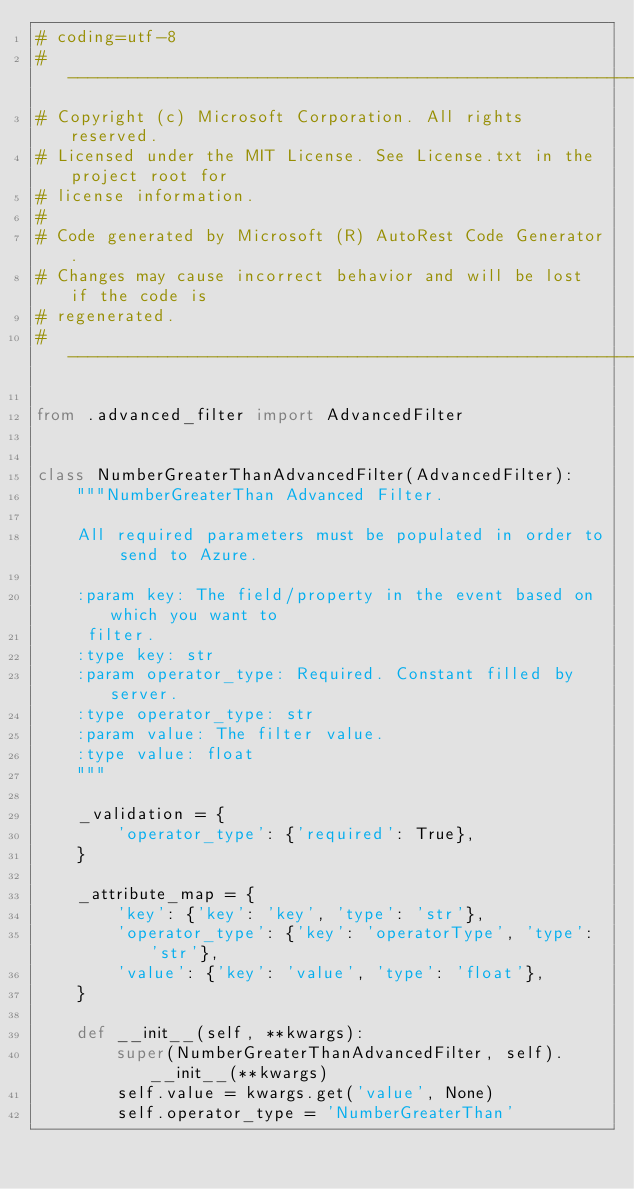Convert code to text. <code><loc_0><loc_0><loc_500><loc_500><_Python_># coding=utf-8
# --------------------------------------------------------------------------
# Copyright (c) Microsoft Corporation. All rights reserved.
# Licensed under the MIT License. See License.txt in the project root for
# license information.
#
# Code generated by Microsoft (R) AutoRest Code Generator.
# Changes may cause incorrect behavior and will be lost if the code is
# regenerated.
# --------------------------------------------------------------------------

from .advanced_filter import AdvancedFilter


class NumberGreaterThanAdvancedFilter(AdvancedFilter):
    """NumberGreaterThan Advanced Filter.

    All required parameters must be populated in order to send to Azure.

    :param key: The field/property in the event based on which you want to
     filter.
    :type key: str
    :param operator_type: Required. Constant filled by server.
    :type operator_type: str
    :param value: The filter value.
    :type value: float
    """

    _validation = {
        'operator_type': {'required': True},
    }

    _attribute_map = {
        'key': {'key': 'key', 'type': 'str'},
        'operator_type': {'key': 'operatorType', 'type': 'str'},
        'value': {'key': 'value', 'type': 'float'},
    }

    def __init__(self, **kwargs):
        super(NumberGreaterThanAdvancedFilter, self).__init__(**kwargs)
        self.value = kwargs.get('value', None)
        self.operator_type = 'NumberGreaterThan'
</code> 